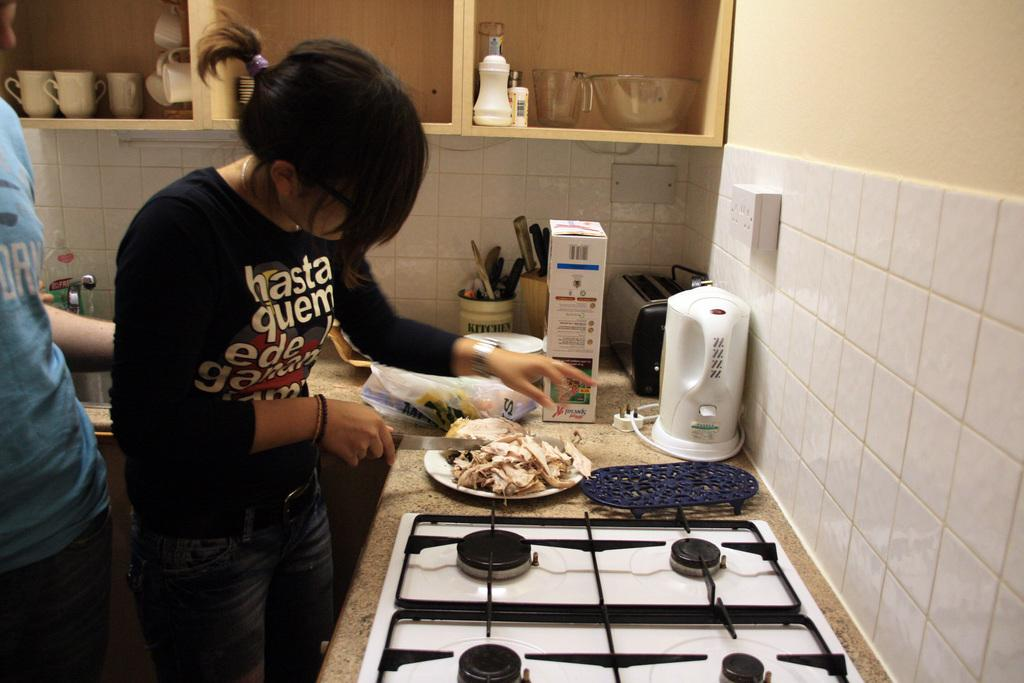Provide a one-sentence caption for the provided image. A woman is cutting chicken while wearing a shirt that says hasta quem. 